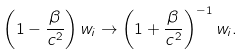<formula> <loc_0><loc_0><loc_500><loc_500>\left ( 1 - \frac { \beta } { c ^ { 2 } } \right ) w _ { i } \rightarrow \left ( 1 + \frac { \beta } { c ^ { 2 } } \right ) ^ { - 1 } w _ { i } .</formula> 